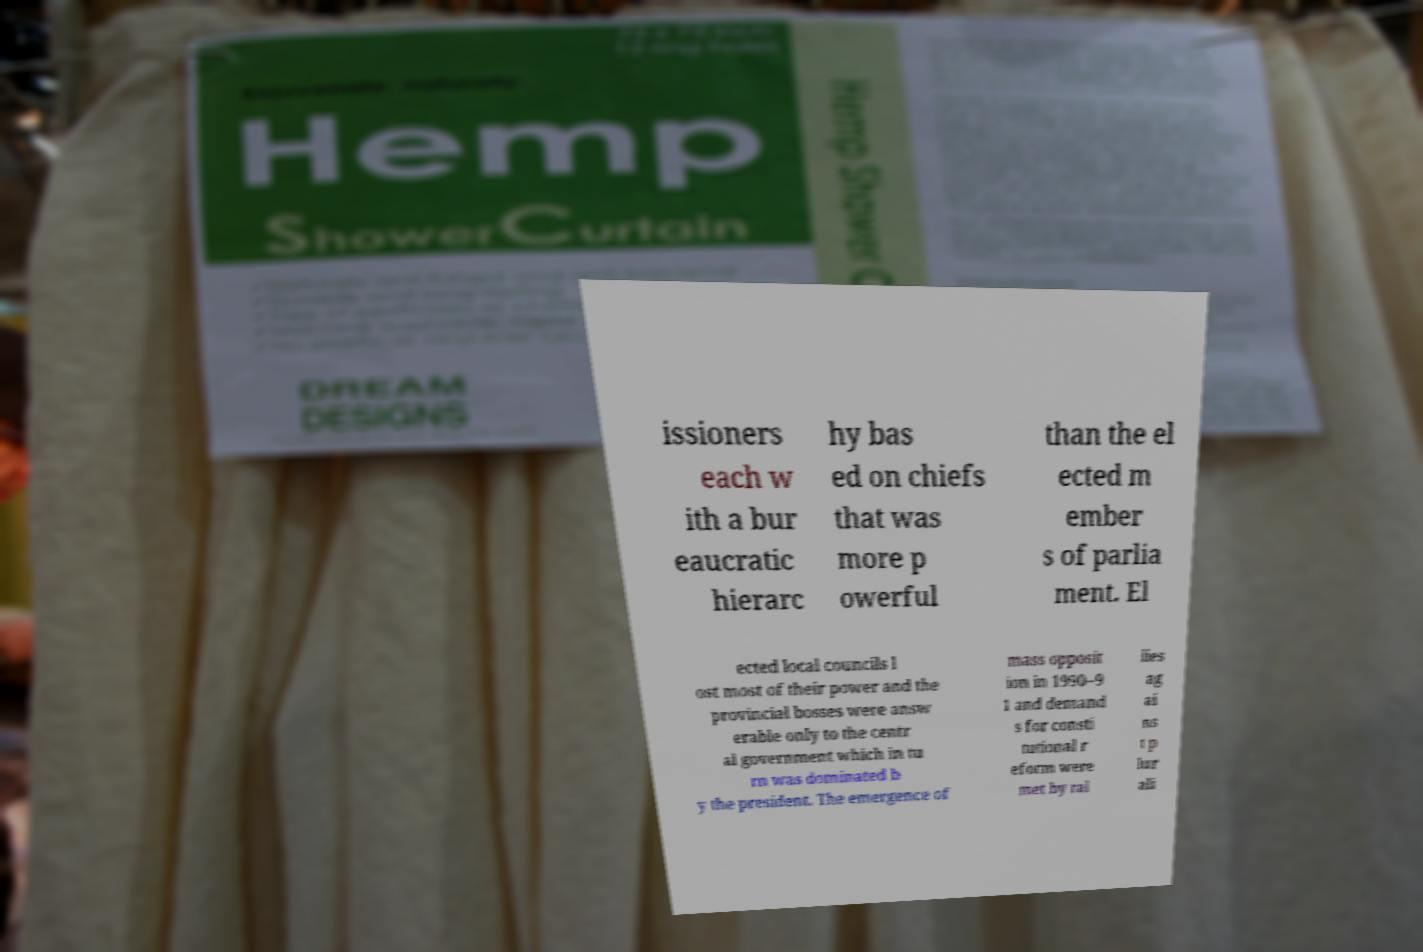What messages or text are displayed in this image? I need them in a readable, typed format. issioners each w ith a bur eaucratic hierarc hy bas ed on chiefs that was more p owerful than the el ected m ember s of parlia ment. El ected local councils l ost most of their power and the provincial bosses were answ erable only to the centr al government which in tu rn was dominated b y the president. The emergence of mass opposit ion in 1990–9 1 and demand s for consti tutional r eform were met by ral lies ag ai ns t p lur ali 